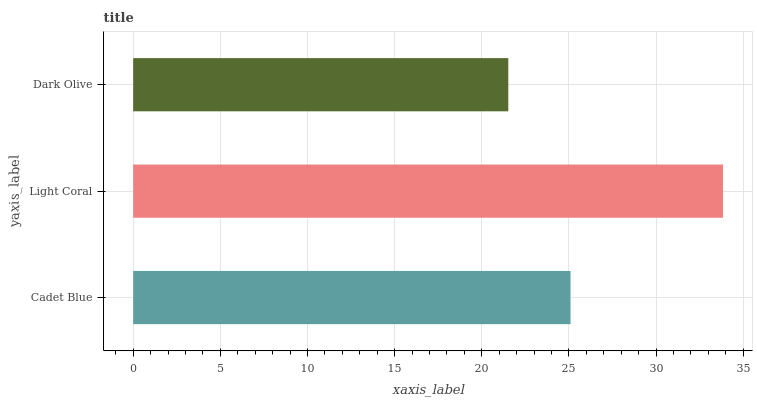Is Dark Olive the minimum?
Answer yes or no. Yes. Is Light Coral the maximum?
Answer yes or no. Yes. Is Light Coral the minimum?
Answer yes or no. No. Is Dark Olive the maximum?
Answer yes or no. No. Is Light Coral greater than Dark Olive?
Answer yes or no. Yes. Is Dark Olive less than Light Coral?
Answer yes or no. Yes. Is Dark Olive greater than Light Coral?
Answer yes or no. No. Is Light Coral less than Dark Olive?
Answer yes or no. No. Is Cadet Blue the high median?
Answer yes or no. Yes. Is Cadet Blue the low median?
Answer yes or no. Yes. Is Light Coral the high median?
Answer yes or no. No. Is Light Coral the low median?
Answer yes or no. No. 